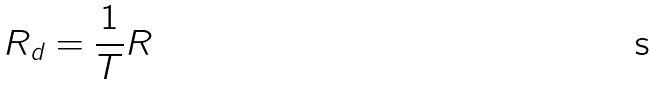Convert formula to latex. <formula><loc_0><loc_0><loc_500><loc_500>R _ { d } = \frac { 1 } { T } R</formula> 